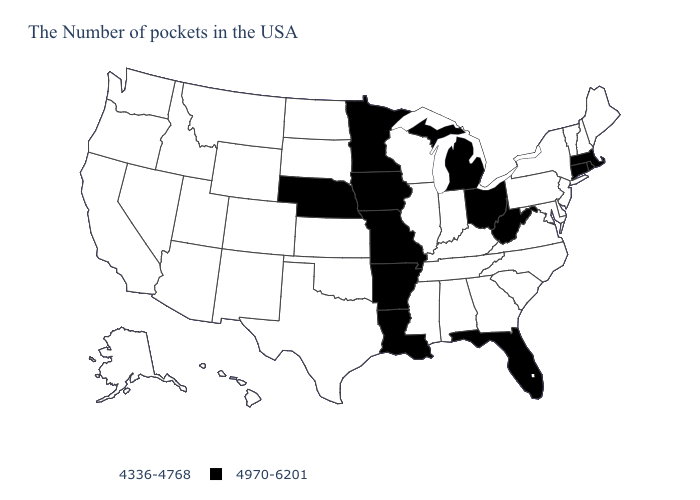What is the value of Indiana?
Give a very brief answer. 4336-4768. Name the states that have a value in the range 4970-6201?
Short answer required. Massachusetts, Rhode Island, Connecticut, West Virginia, Ohio, Florida, Michigan, Louisiana, Missouri, Arkansas, Minnesota, Iowa, Nebraska. Name the states that have a value in the range 4336-4768?
Short answer required. Maine, New Hampshire, Vermont, New York, New Jersey, Delaware, Maryland, Pennsylvania, Virginia, North Carolina, South Carolina, Georgia, Kentucky, Indiana, Alabama, Tennessee, Wisconsin, Illinois, Mississippi, Kansas, Oklahoma, Texas, South Dakota, North Dakota, Wyoming, Colorado, New Mexico, Utah, Montana, Arizona, Idaho, Nevada, California, Washington, Oregon, Alaska, Hawaii. Among the states that border Minnesota , which have the highest value?
Concise answer only. Iowa. Name the states that have a value in the range 4970-6201?
Write a very short answer. Massachusetts, Rhode Island, Connecticut, West Virginia, Ohio, Florida, Michigan, Louisiana, Missouri, Arkansas, Minnesota, Iowa, Nebraska. What is the highest value in the Northeast ?
Keep it brief. 4970-6201. Among the states that border Kentucky , which have the lowest value?
Give a very brief answer. Virginia, Indiana, Tennessee, Illinois. Among the states that border California , which have the highest value?
Short answer required. Arizona, Nevada, Oregon. Name the states that have a value in the range 4336-4768?
Short answer required. Maine, New Hampshire, Vermont, New York, New Jersey, Delaware, Maryland, Pennsylvania, Virginia, North Carolina, South Carolina, Georgia, Kentucky, Indiana, Alabama, Tennessee, Wisconsin, Illinois, Mississippi, Kansas, Oklahoma, Texas, South Dakota, North Dakota, Wyoming, Colorado, New Mexico, Utah, Montana, Arizona, Idaho, Nevada, California, Washington, Oregon, Alaska, Hawaii. What is the value of Hawaii?
Short answer required. 4336-4768. What is the highest value in the USA?
Give a very brief answer. 4970-6201. What is the highest value in the MidWest ?
Be succinct. 4970-6201. What is the value of Washington?
Write a very short answer. 4336-4768. What is the value of Missouri?
Write a very short answer. 4970-6201. Does New Hampshire have the lowest value in the Northeast?
Quick response, please. Yes. 